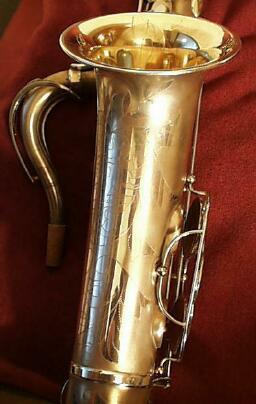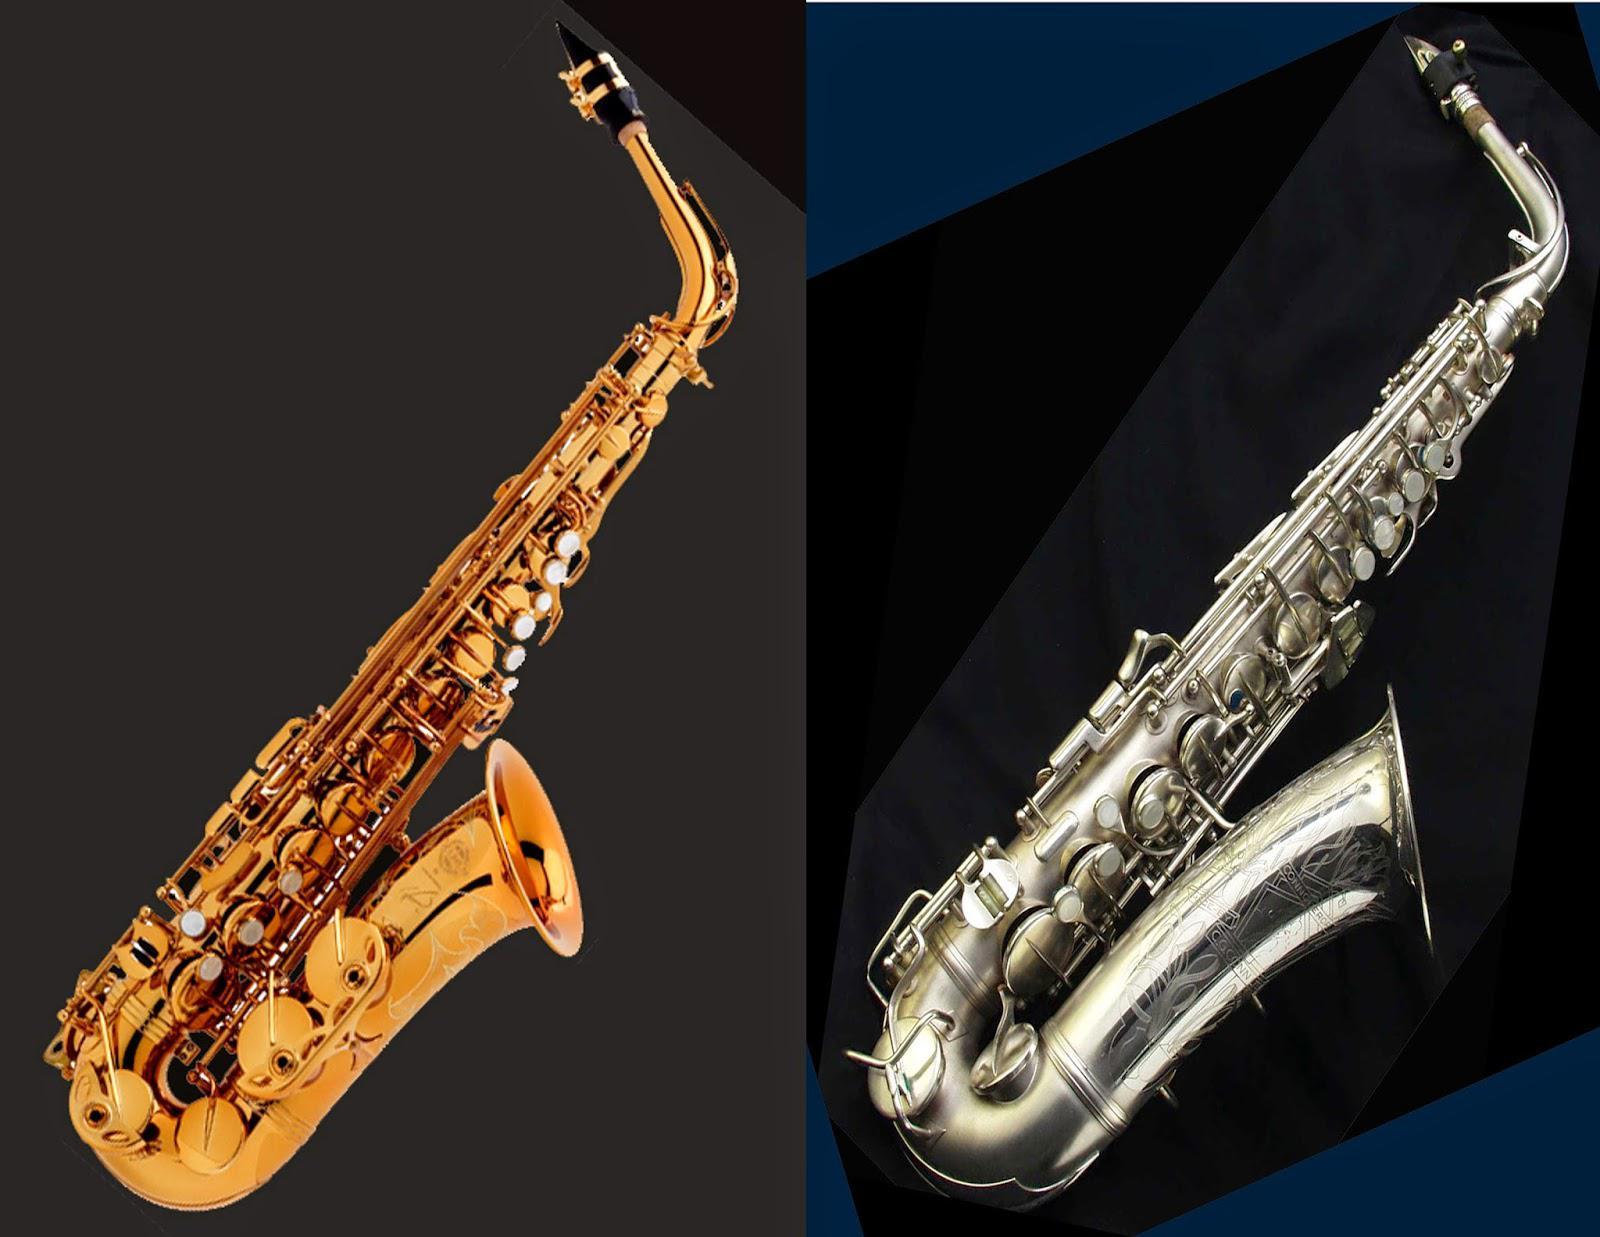The first image is the image on the left, the second image is the image on the right. Considering the images on both sides, is "One image shows a saxophone displayed on black with its mouthpiece separated." valid? Answer yes or no. No. 